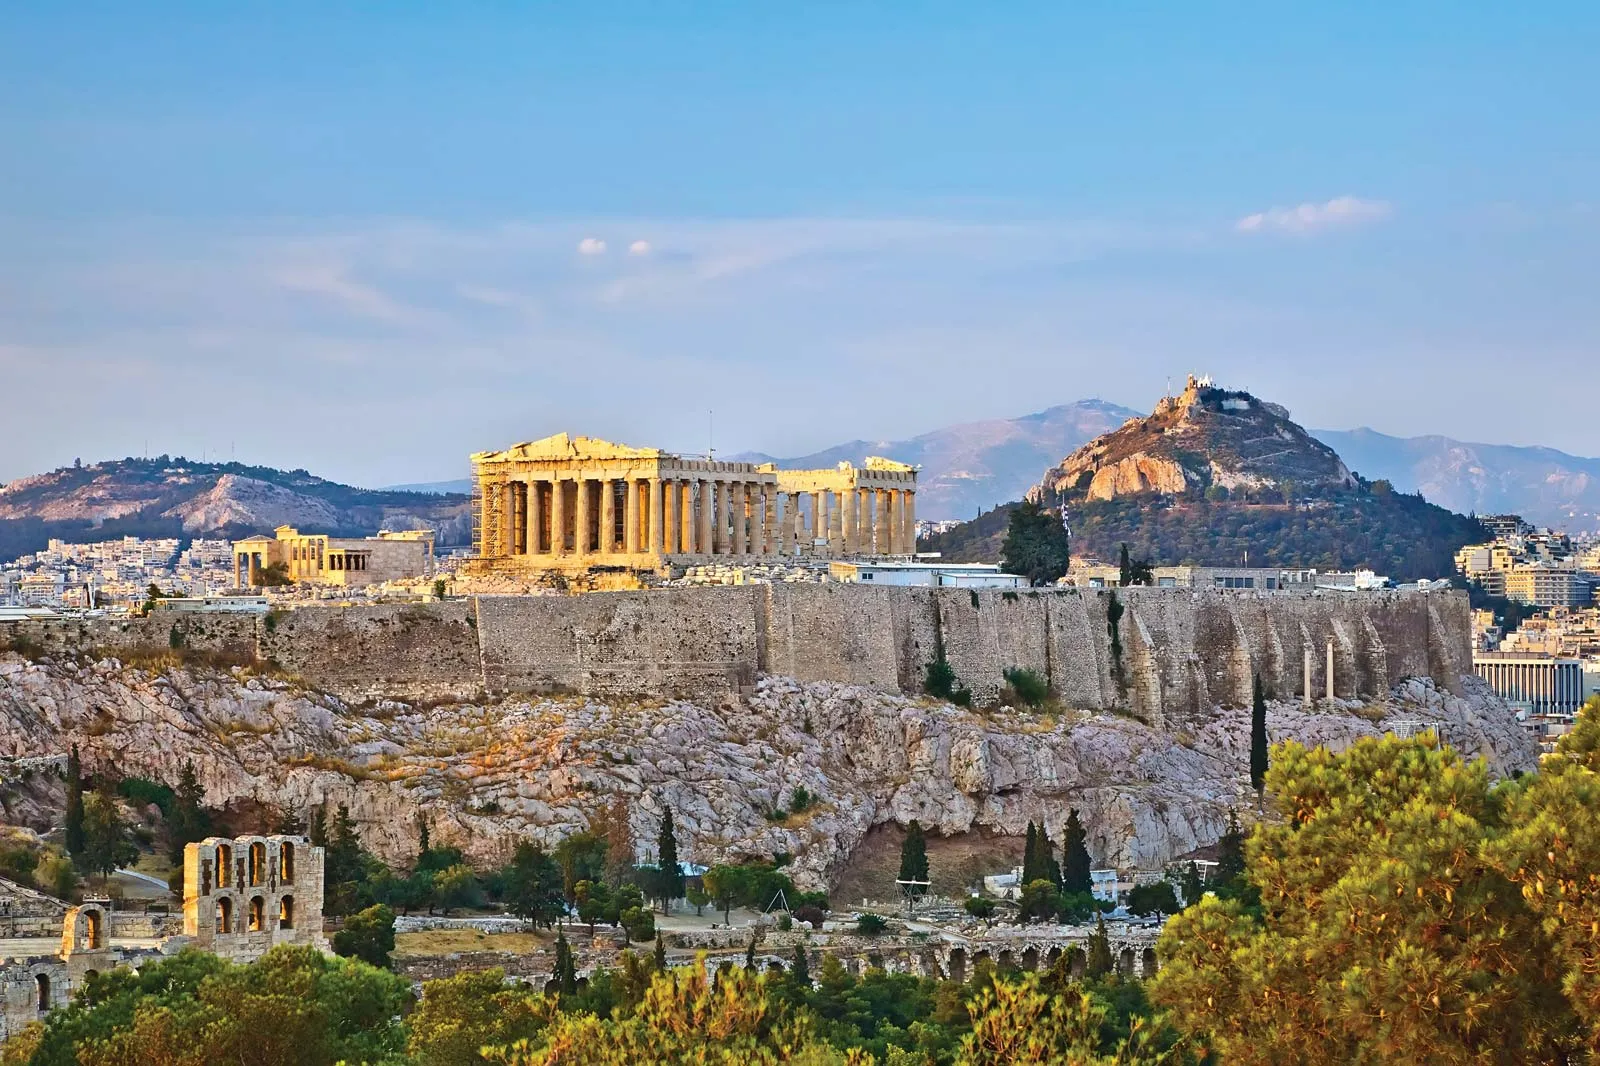How does the Acropolis reflect the civilization of ancient Greece? The Acropolis is a profound reflection of ancient Greek civilization, embodying their advancements in architecture, art, and philosophy. It stands as a testament to the Greeks' architectural ingenuity, with structures like the Parthenon showcasing their mastery over forms, proportions, and construction techniques. The Acropolis also represents the religious and cultural values of the Athenians, with temples dedicated to deities like Athena, symbolizing the protector of the city. Politically, it signifies the height of Athenian democracy and imperial power, mirroring the intellectual and artistic flourishing that defined one of history's most influential civilizations. The preservation of such monumental sites illustrates the Greek commitment to honoring their heritage, wisdom, and contributions to the collective human experience. What if the Acropolis could tell stories of its past inhabitants? If the Acropolis could narrate its past, it would recount tales of gods and mortals intertwined in the fabric of its existence. It would speak of grand religious ceremonies, the reverence shown to Athena by the Athenians, and the intricate rituals performed within its sacred precincts. The walls would echo with the debates of philosophers like Socrates and Plato, discussing democracy, ethics, and the nature of reality in the shadows of the Parthenon. The Acropolis would tell of artisans chiseling marble with unwavering dedication, creating masterpieces that have stood the test of time. It would recall the bustling activities in the Agora, where citizens gathered to discuss matters of state, trade, and everyday life. Through wars, conquests, and restorations, the Acropolis has witnessed the rise and fall of empires, silently standing as a guardian of countless human stories and a symbol of enduring legacy. Could you give a short story about a day in ancient Athens involving the Acropolis? In the heart of ancient Athens, a young boy named Alexios eagerly climbed the steps of the Acropolis with his father. It was the day of the Panathenaic Festival, and the entire city was in jubilant spirits. Citizens adorned in their finest garments thronged the sacred hill, chanting hymns dedicated to Athena. As they reached the Parthenon, Alexios marveled at the sheer magnificence of the temple, its white marble columns gleaming under the sun. Priests performed rituals, while artists showcased their skills in honor of the goddess. For Alexios, the day was magical, filled with music, dance, and a profound sense of community. Little did he know, this very hill would continue to inspire awe for millennia to come, standing witness to the timeless spirit of Athens. 